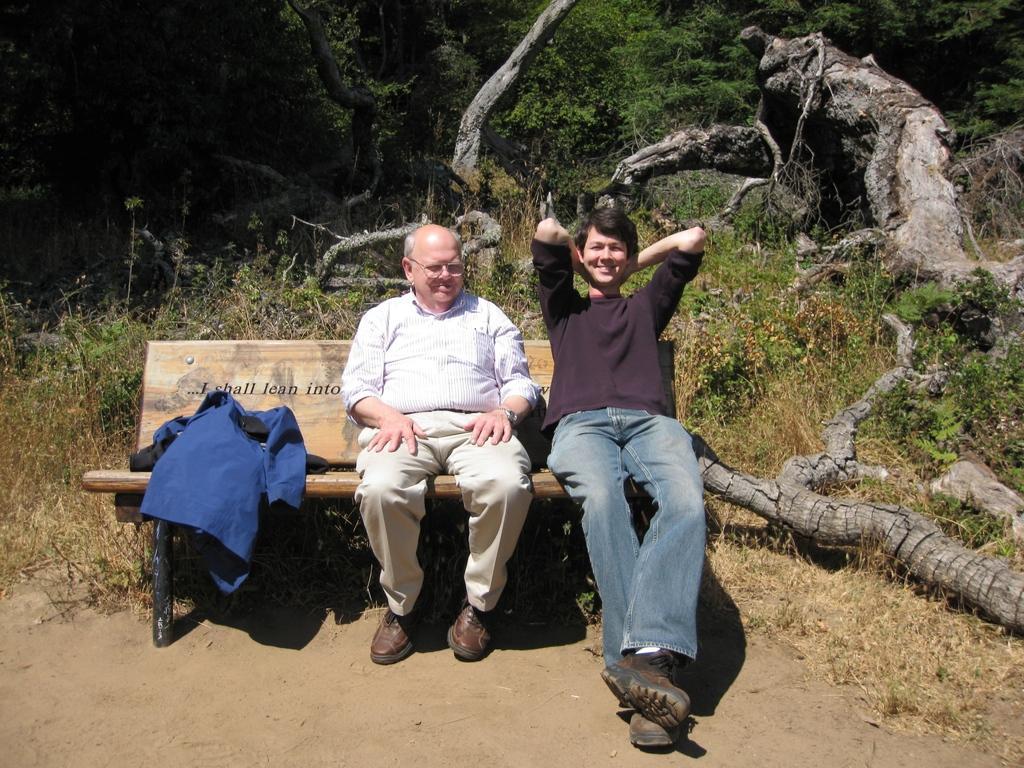In one or two sentences, can you explain what this image depicts? In this picture there is a boy wearing brown color t- shirt is sitting on the bench, smiling and giving a pose. Beside there is a old man sitting and smiling. In the background we can see the tree trunks on the ground and some trees. 